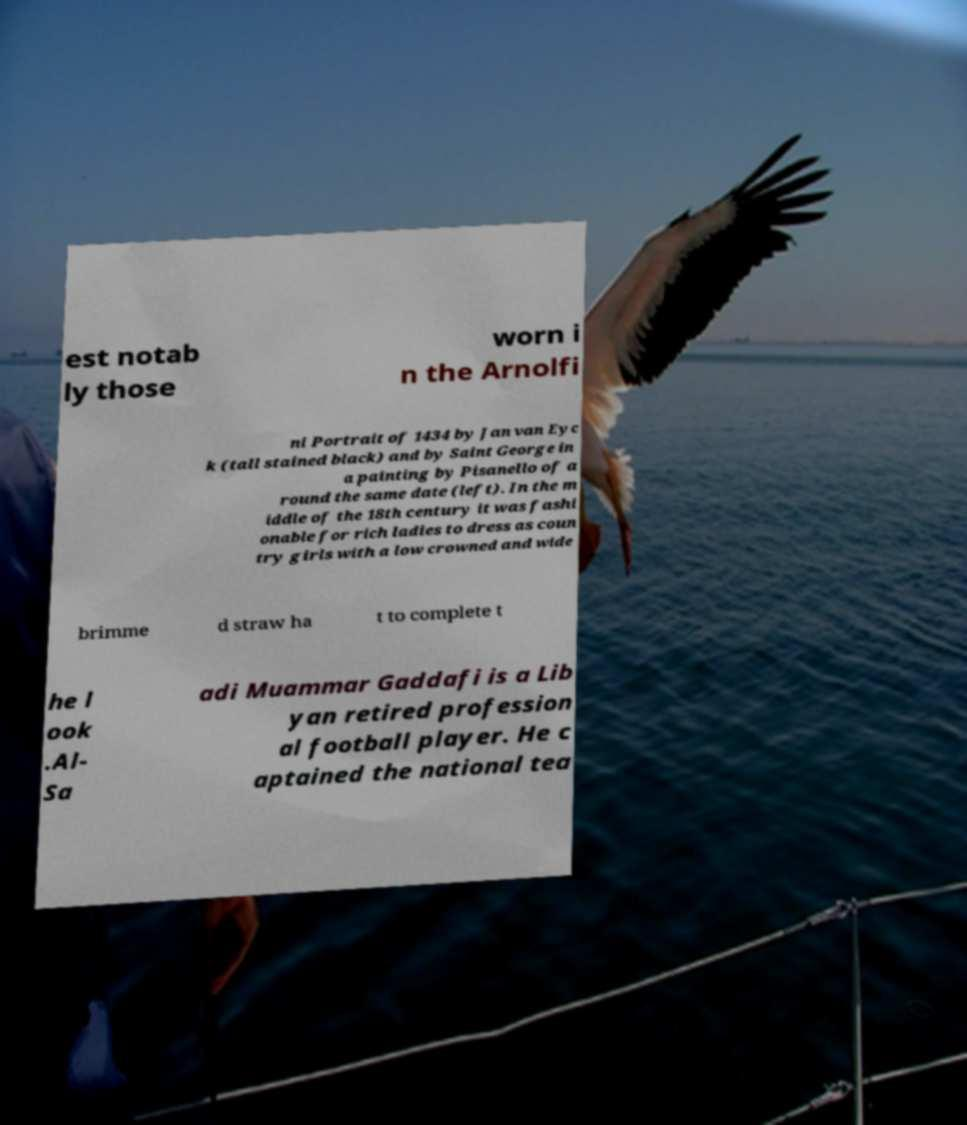Can you accurately transcribe the text from the provided image for me? est notab ly those worn i n the Arnolfi ni Portrait of 1434 by Jan van Eyc k (tall stained black) and by Saint George in a painting by Pisanello of a round the same date (left). In the m iddle of the 18th century it was fashi onable for rich ladies to dress as coun try girls with a low crowned and wide brimme d straw ha t to complete t he l ook .Al- Sa adi Muammar Gaddafi is a Lib yan retired profession al football player. He c aptained the national tea 